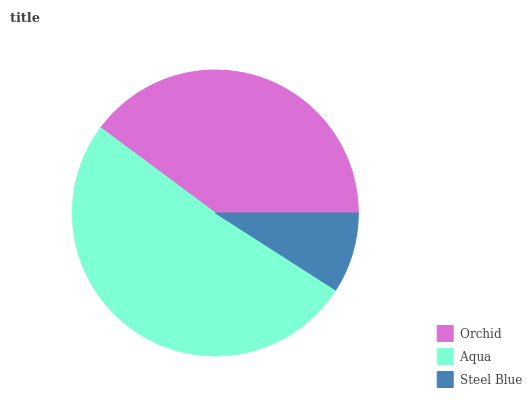Is Steel Blue the minimum?
Answer yes or no. Yes. Is Aqua the maximum?
Answer yes or no. Yes. Is Aqua the minimum?
Answer yes or no. No. Is Steel Blue the maximum?
Answer yes or no. No. Is Aqua greater than Steel Blue?
Answer yes or no. Yes. Is Steel Blue less than Aqua?
Answer yes or no. Yes. Is Steel Blue greater than Aqua?
Answer yes or no. No. Is Aqua less than Steel Blue?
Answer yes or no. No. Is Orchid the high median?
Answer yes or no. Yes. Is Orchid the low median?
Answer yes or no. Yes. Is Steel Blue the high median?
Answer yes or no. No. Is Aqua the low median?
Answer yes or no. No. 